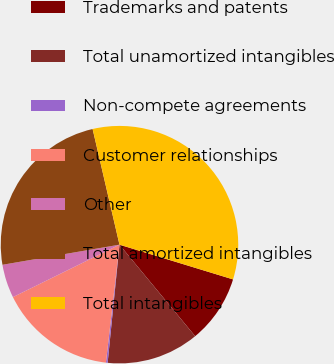Convert chart to OTSL. <chart><loc_0><loc_0><loc_500><loc_500><pie_chart><fcel>Trademarks and patents<fcel>Total unamortized intangibles<fcel>Non-compete agreements<fcel>Customer relationships<fcel>Other<fcel>Total amortized intangibles<fcel>Total intangibles<nl><fcel>9.28%<fcel>12.59%<fcel>0.23%<fcel>15.9%<fcel>4.57%<fcel>24.08%<fcel>33.36%<nl></chart> 